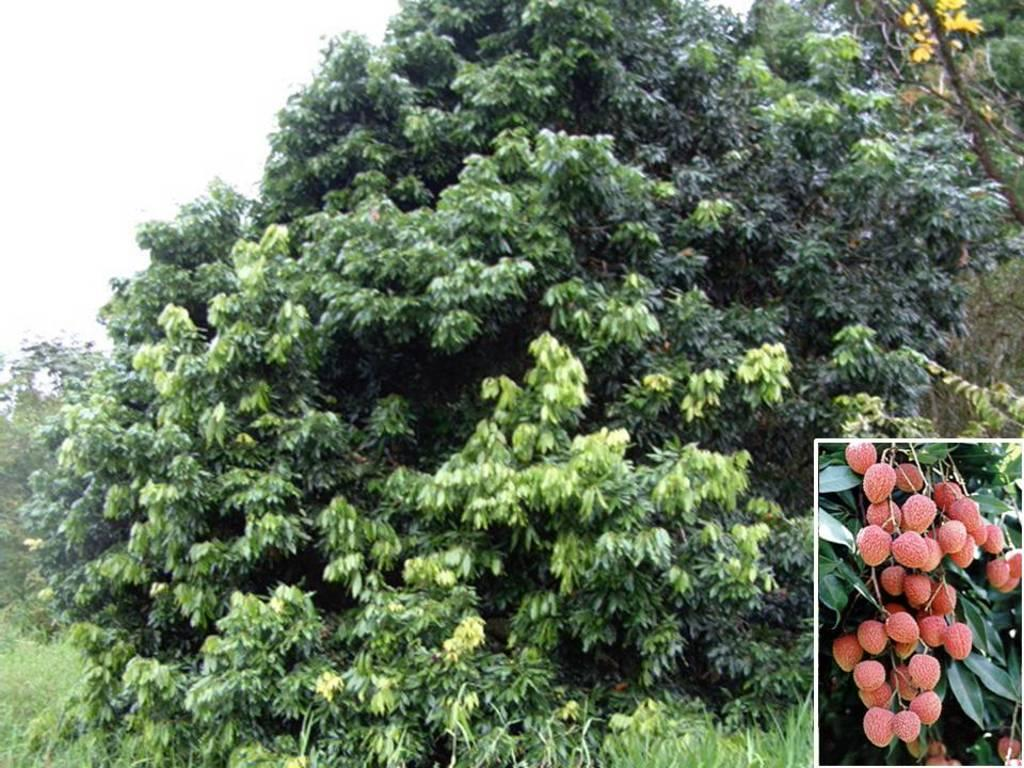What type of plant is visible in the image with fruits? There is a tree with fruits in the image. Are there any other plants or trees depicted in the image? Yes, there is another image of trees in the image. What type of ground cover is present in the image? Grass is present on the floor. What is the condition of the sky in the image? The sky is clear in the image. Where is the hook located in the image? There is no hook present in the image. What type of card can be seen in the image? There is no card present in the image. 